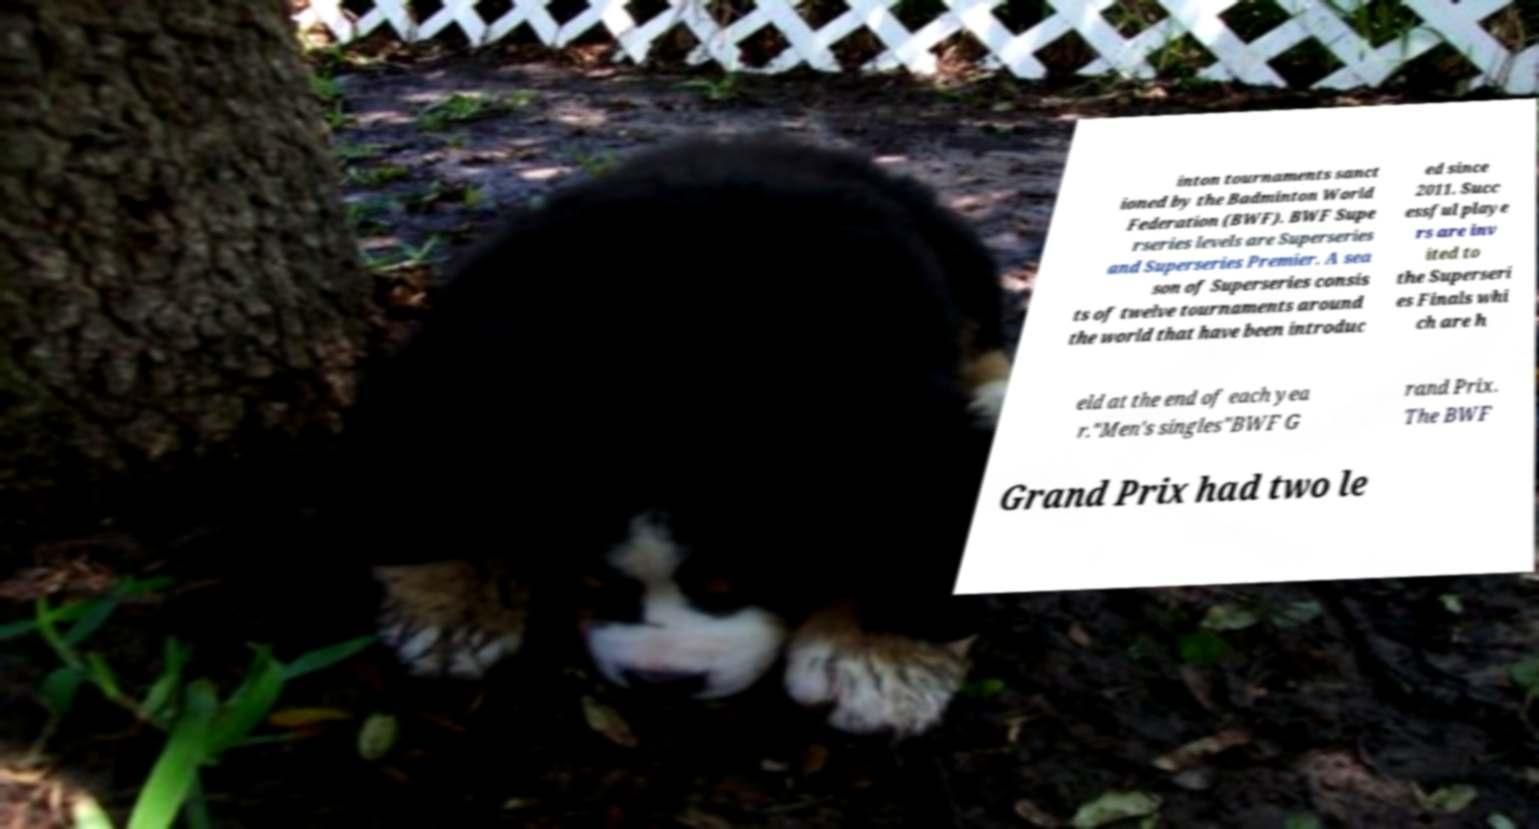For documentation purposes, I need the text within this image transcribed. Could you provide that? inton tournaments sanct ioned by the Badminton World Federation (BWF). BWF Supe rseries levels are Superseries and Superseries Premier. A sea son of Superseries consis ts of twelve tournaments around the world that have been introduc ed since 2011. Succ essful playe rs are inv ited to the Superseri es Finals whi ch are h eld at the end of each yea r."Men's singles"BWF G rand Prix. The BWF Grand Prix had two le 